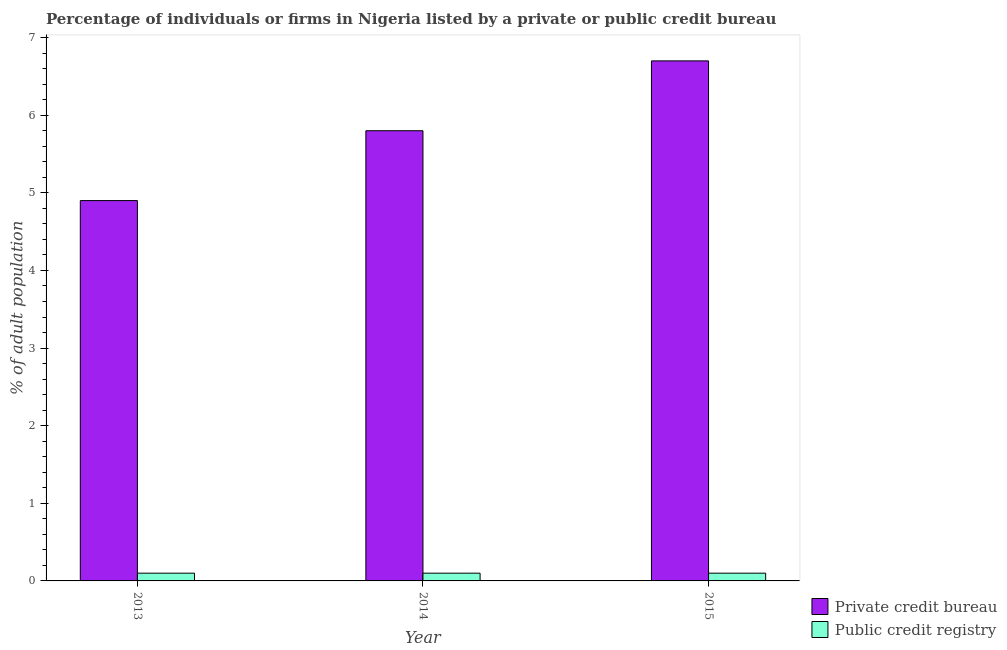How many different coloured bars are there?
Your answer should be very brief. 2. How many groups of bars are there?
Provide a short and direct response. 3. Are the number of bars on each tick of the X-axis equal?
Provide a succinct answer. Yes. How many bars are there on the 1st tick from the left?
Give a very brief answer. 2. What is the label of the 2nd group of bars from the left?
Your answer should be compact. 2014. In how many cases, is the number of bars for a given year not equal to the number of legend labels?
Give a very brief answer. 0. What is the percentage of firms listed by private credit bureau in 2015?
Your response must be concise. 6.7. Across all years, what is the maximum percentage of firms listed by public credit bureau?
Keep it short and to the point. 0.1. Across all years, what is the minimum percentage of firms listed by private credit bureau?
Offer a terse response. 4.9. In which year was the percentage of firms listed by public credit bureau maximum?
Give a very brief answer. 2013. In which year was the percentage of firms listed by private credit bureau minimum?
Give a very brief answer. 2013. What is the total percentage of firms listed by public credit bureau in the graph?
Provide a succinct answer. 0.3. What is the average percentage of firms listed by public credit bureau per year?
Ensure brevity in your answer.  0.1. In the year 2013, what is the difference between the percentage of firms listed by private credit bureau and percentage of firms listed by public credit bureau?
Make the answer very short. 0. In how many years, is the percentage of firms listed by public credit bureau greater than 5.2 %?
Your response must be concise. 0. What is the ratio of the percentage of firms listed by private credit bureau in 2013 to that in 2015?
Provide a short and direct response. 0.73. Is the percentage of firms listed by public credit bureau in 2013 less than that in 2015?
Keep it short and to the point. No. What is the difference between the highest and the second highest percentage of firms listed by public credit bureau?
Keep it short and to the point. 0. What does the 2nd bar from the left in 2015 represents?
Ensure brevity in your answer.  Public credit registry. What does the 2nd bar from the right in 2014 represents?
Offer a very short reply. Private credit bureau. Are all the bars in the graph horizontal?
Make the answer very short. No. How many years are there in the graph?
Give a very brief answer. 3. What is the difference between two consecutive major ticks on the Y-axis?
Your response must be concise. 1. What is the title of the graph?
Keep it short and to the point. Percentage of individuals or firms in Nigeria listed by a private or public credit bureau. What is the label or title of the X-axis?
Ensure brevity in your answer.  Year. What is the label or title of the Y-axis?
Offer a very short reply. % of adult population. What is the % of adult population in Public credit registry in 2014?
Offer a very short reply. 0.1. Across all years, what is the maximum % of adult population of Public credit registry?
Your answer should be compact. 0.1. Across all years, what is the minimum % of adult population of Private credit bureau?
Keep it short and to the point. 4.9. What is the total % of adult population in Public credit registry in the graph?
Offer a very short reply. 0.3. What is the difference between the % of adult population of Public credit registry in 2013 and that in 2014?
Your response must be concise. 0. What is the difference between the % of adult population of Private credit bureau in 2013 and that in 2015?
Make the answer very short. -1.8. What is the difference between the % of adult population of Private credit bureau in 2014 and that in 2015?
Give a very brief answer. -0.9. What is the difference between the % of adult population in Public credit registry in 2014 and that in 2015?
Offer a terse response. 0. What is the difference between the % of adult population in Private credit bureau in 2014 and the % of adult population in Public credit registry in 2015?
Make the answer very short. 5.7. What is the average % of adult population of Public credit registry per year?
Your answer should be very brief. 0.1. In the year 2015, what is the difference between the % of adult population of Private credit bureau and % of adult population of Public credit registry?
Your answer should be very brief. 6.6. What is the ratio of the % of adult population of Private credit bureau in 2013 to that in 2014?
Your response must be concise. 0.84. What is the ratio of the % of adult population in Public credit registry in 2013 to that in 2014?
Keep it short and to the point. 1. What is the ratio of the % of adult population in Private credit bureau in 2013 to that in 2015?
Ensure brevity in your answer.  0.73. What is the ratio of the % of adult population in Public credit registry in 2013 to that in 2015?
Provide a succinct answer. 1. What is the ratio of the % of adult population in Private credit bureau in 2014 to that in 2015?
Provide a short and direct response. 0.87. What is the ratio of the % of adult population in Public credit registry in 2014 to that in 2015?
Provide a succinct answer. 1. What is the difference between the highest and the second highest % of adult population in Public credit registry?
Ensure brevity in your answer.  0. What is the difference between the highest and the lowest % of adult population of Public credit registry?
Offer a terse response. 0. 